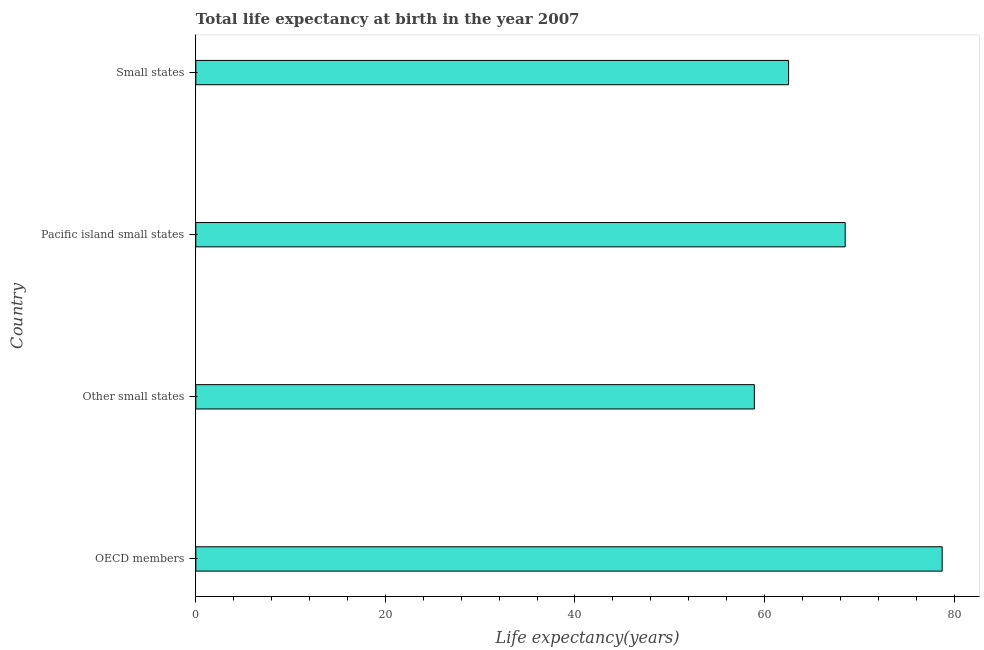Does the graph contain grids?
Keep it short and to the point. No. What is the title of the graph?
Ensure brevity in your answer.  Total life expectancy at birth in the year 2007. What is the label or title of the X-axis?
Keep it short and to the point. Life expectancy(years). What is the life expectancy at birth in Small states?
Offer a very short reply. 62.54. Across all countries, what is the maximum life expectancy at birth?
Keep it short and to the point. 78.75. Across all countries, what is the minimum life expectancy at birth?
Your response must be concise. 58.93. In which country was the life expectancy at birth minimum?
Your answer should be compact. Other small states. What is the sum of the life expectancy at birth?
Keep it short and to the point. 268.73. What is the difference between the life expectancy at birth in Other small states and Pacific island small states?
Provide a short and direct response. -9.58. What is the average life expectancy at birth per country?
Ensure brevity in your answer.  67.18. What is the median life expectancy at birth?
Ensure brevity in your answer.  65.53. What is the ratio of the life expectancy at birth in Other small states to that in Small states?
Offer a very short reply. 0.94. Is the life expectancy at birth in Other small states less than that in Pacific island small states?
Make the answer very short. Yes. Is the difference between the life expectancy at birth in Other small states and Pacific island small states greater than the difference between any two countries?
Offer a very short reply. No. What is the difference between the highest and the second highest life expectancy at birth?
Your answer should be compact. 10.23. Is the sum of the life expectancy at birth in Pacific island small states and Small states greater than the maximum life expectancy at birth across all countries?
Your response must be concise. Yes. What is the difference between the highest and the lowest life expectancy at birth?
Give a very brief answer. 19.82. Are all the bars in the graph horizontal?
Your answer should be very brief. Yes. How many countries are there in the graph?
Your answer should be compact. 4. What is the difference between two consecutive major ticks on the X-axis?
Provide a succinct answer. 20. What is the Life expectancy(years) of OECD members?
Make the answer very short. 78.75. What is the Life expectancy(years) in Other small states?
Ensure brevity in your answer.  58.93. What is the Life expectancy(years) in Pacific island small states?
Your answer should be compact. 68.51. What is the Life expectancy(years) in Small states?
Provide a short and direct response. 62.54. What is the difference between the Life expectancy(years) in OECD members and Other small states?
Offer a terse response. 19.82. What is the difference between the Life expectancy(years) in OECD members and Pacific island small states?
Provide a short and direct response. 10.23. What is the difference between the Life expectancy(years) in OECD members and Small states?
Your response must be concise. 16.21. What is the difference between the Life expectancy(years) in Other small states and Pacific island small states?
Make the answer very short. -9.58. What is the difference between the Life expectancy(years) in Other small states and Small states?
Make the answer very short. -3.61. What is the difference between the Life expectancy(years) in Pacific island small states and Small states?
Your answer should be very brief. 5.97. What is the ratio of the Life expectancy(years) in OECD members to that in Other small states?
Your answer should be very brief. 1.34. What is the ratio of the Life expectancy(years) in OECD members to that in Pacific island small states?
Your response must be concise. 1.15. What is the ratio of the Life expectancy(years) in OECD members to that in Small states?
Ensure brevity in your answer.  1.26. What is the ratio of the Life expectancy(years) in Other small states to that in Pacific island small states?
Make the answer very short. 0.86. What is the ratio of the Life expectancy(years) in Other small states to that in Small states?
Offer a very short reply. 0.94. What is the ratio of the Life expectancy(years) in Pacific island small states to that in Small states?
Ensure brevity in your answer.  1.09. 